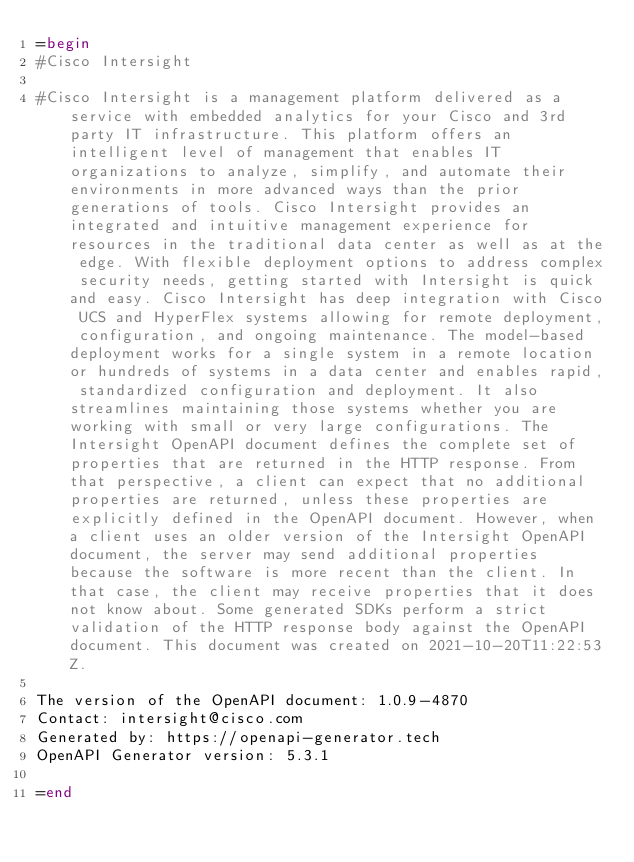<code> <loc_0><loc_0><loc_500><loc_500><_Ruby_>=begin
#Cisco Intersight

#Cisco Intersight is a management platform delivered as a service with embedded analytics for your Cisco and 3rd party IT infrastructure. This platform offers an intelligent level of management that enables IT organizations to analyze, simplify, and automate their environments in more advanced ways than the prior generations of tools. Cisco Intersight provides an integrated and intuitive management experience for resources in the traditional data center as well as at the edge. With flexible deployment options to address complex security needs, getting started with Intersight is quick and easy. Cisco Intersight has deep integration with Cisco UCS and HyperFlex systems allowing for remote deployment, configuration, and ongoing maintenance. The model-based deployment works for a single system in a remote location or hundreds of systems in a data center and enables rapid, standardized configuration and deployment. It also streamlines maintaining those systems whether you are working with small or very large configurations. The Intersight OpenAPI document defines the complete set of properties that are returned in the HTTP response. From that perspective, a client can expect that no additional properties are returned, unless these properties are explicitly defined in the OpenAPI document. However, when a client uses an older version of the Intersight OpenAPI document, the server may send additional properties because the software is more recent than the client. In that case, the client may receive properties that it does not know about. Some generated SDKs perform a strict validation of the HTTP response body against the OpenAPI document. This document was created on 2021-10-20T11:22:53Z.

The version of the OpenAPI document: 1.0.9-4870
Contact: intersight@cisco.com
Generated by: https://openapi-generator.tech
OpenAPI Generator version: 5.3.1

=end
</code> 